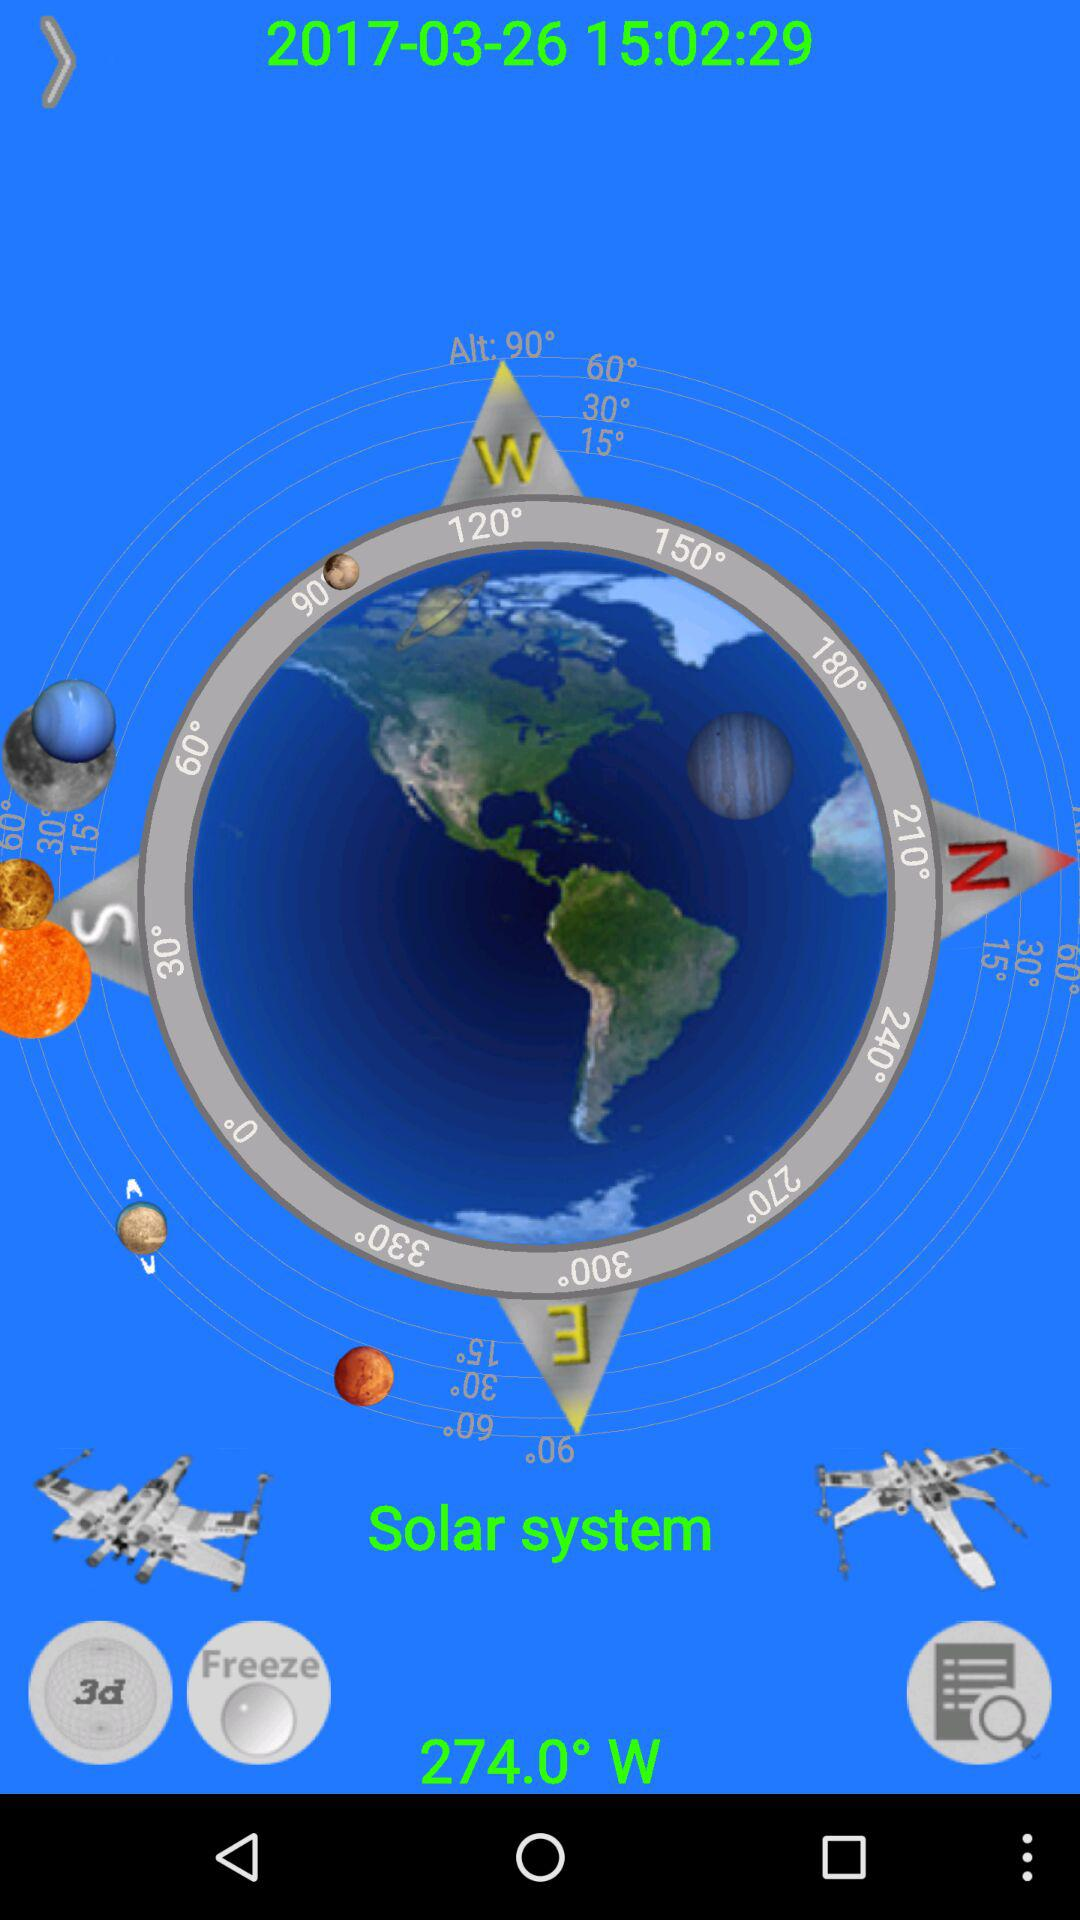How many degrees is the compass pointing?
Answer the question using a single word or phrase. 274.0° W 